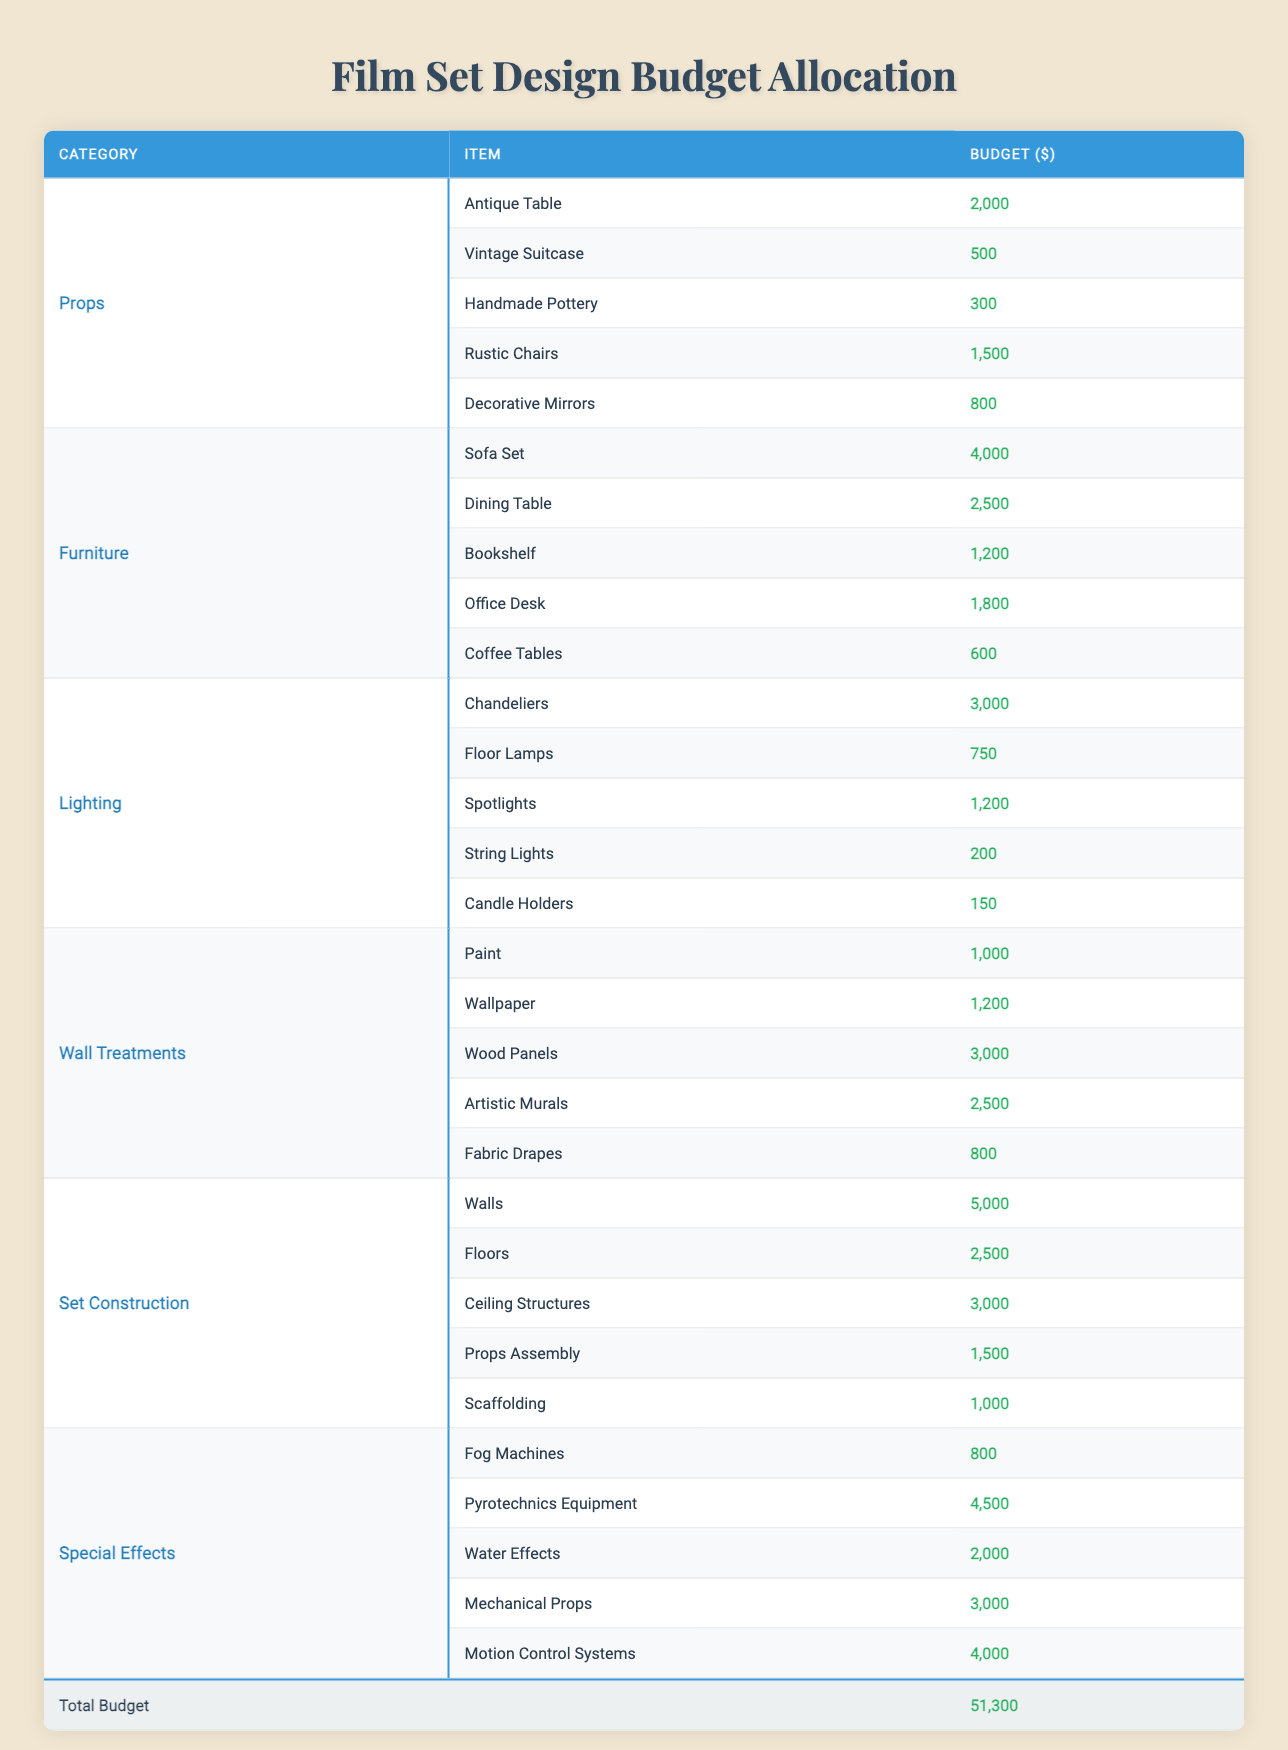What is the total budget allocated for Furniture? To find this, we add the budgets for all items under the Furniture category: Sofa Set (4000) + Dining Table (2500) + Bookshelf (1200) + Office Desk (1800) + Coffee Tables (600) = 10,100.
Answer: 10,100 Which item has the highest budget in the Wall Treatments category? In the Wall Treatments category, we check the budgets: Paint (1000), Wallpaper (1200), Wood Panels (3000), Artistic Murals (2500), Fabric Drapes (800). The highest is Wood Panels at 3000.
Answer: Wood Panels Is the budget for Decorative Mirrors greater than 1000? The budget for Decorative Mirrors is 800. Since 800 is less than 1000, the statement is false.
Answer: No What is the average budget for all items under the Props category? The total budget for the Props category is 2000 + 500 + 300 + 1500 + 800 = 4100. There are 5 items, so the average budget is 4100 / 5 = 820.
Answer: 820 Which category has the largest total budget allocation? We sum the budget for each category: Props (4100), Furniture (10100), Lighting (5100), Wall Treatments (4800), Set Construction (12500), Special Effects (11500). The largest total is for Set Construction at 12500.
Answer: Set Construction How much more is allocated for Pyrotechnics Equipment compared to Fog Machines? The budget for Pyrotechnics Equipment is 4500 and for Fog Machines, it is 800. The difference is 4500 - 800 = 3700.
Answer: 3700 If you want to make a set focusing only on Special Effects and Lighting, what budget would you need? We add the totals for Lighting (5100) and Special Effects (11500): 5100 + 11500 = 16600.
Answer: 16,600 What is the total budget for all categories combined? Summing each category's total: Props (4100), Furniture (10100), Lighting (5100), Wall Treatments (4800), Set Construction (12500), Special Effects (11500), gives a total of 51300.
Answer: 51,300 Is the budget for the Sofa Set equal to the combined budgets of the Office Desk and Coffee Tables? The Sofa Set costs 4000, while Office Desk (1800) + Coffee Tables (600) = 2400. 4000 is greater than 2400, thus the statement is false.
Answer: No What would the average budget be if only the top three highest budget items from Special Effects were considered? The top three highest budgets are Pyrotechnics Equipment (4500), Motion Control Systems (4000), and Mechanical Props (3000). Their sum is 4500 + 4000 + 3000 = 11500. The average for those 3 items is 11500 / 3 = 3833.33.
Answer: 3,833.33 